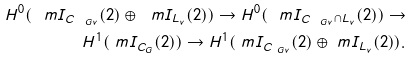Convert formula to latex. <formula><loc_0><loc_0><loc_500><loc_500>H ^ { 0 } ( \ m I _ { C _ { \ G v } } ( 2 ) \oplus \ m I _ { L _ { v } } ( 2 ) ) \to H ^ { 0 } ( \ m I _ { C _ { \ G v } \cap L _ { v } } ( 2 ) ) \to \\ H ^ { 1 } ( \ m I _ { C _ { G } } ( 2 ) ) \to H ^ { 1 } ( \ m I _ { C _ { \ G v } } ( 2 ) \oplus \ m I _ { L _ { v } } ( 2 ) ) .</formula> 